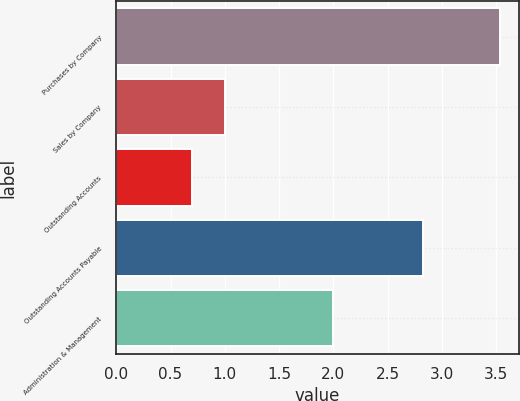Convert chart to OTSL. <chart><loc_0><loc_0><loc_500><loc_500><bar_chart><fcel>Purchases by Company<fcel>Sales by Company<fcel>Outstanding Accounts<fcel>Outstanding Accounts Payable<fcel>Administration & Management<nl><fcel>3.53<fcel>1<fcel>0.7<fcel>2.83<fcel>2<nl></chart> 